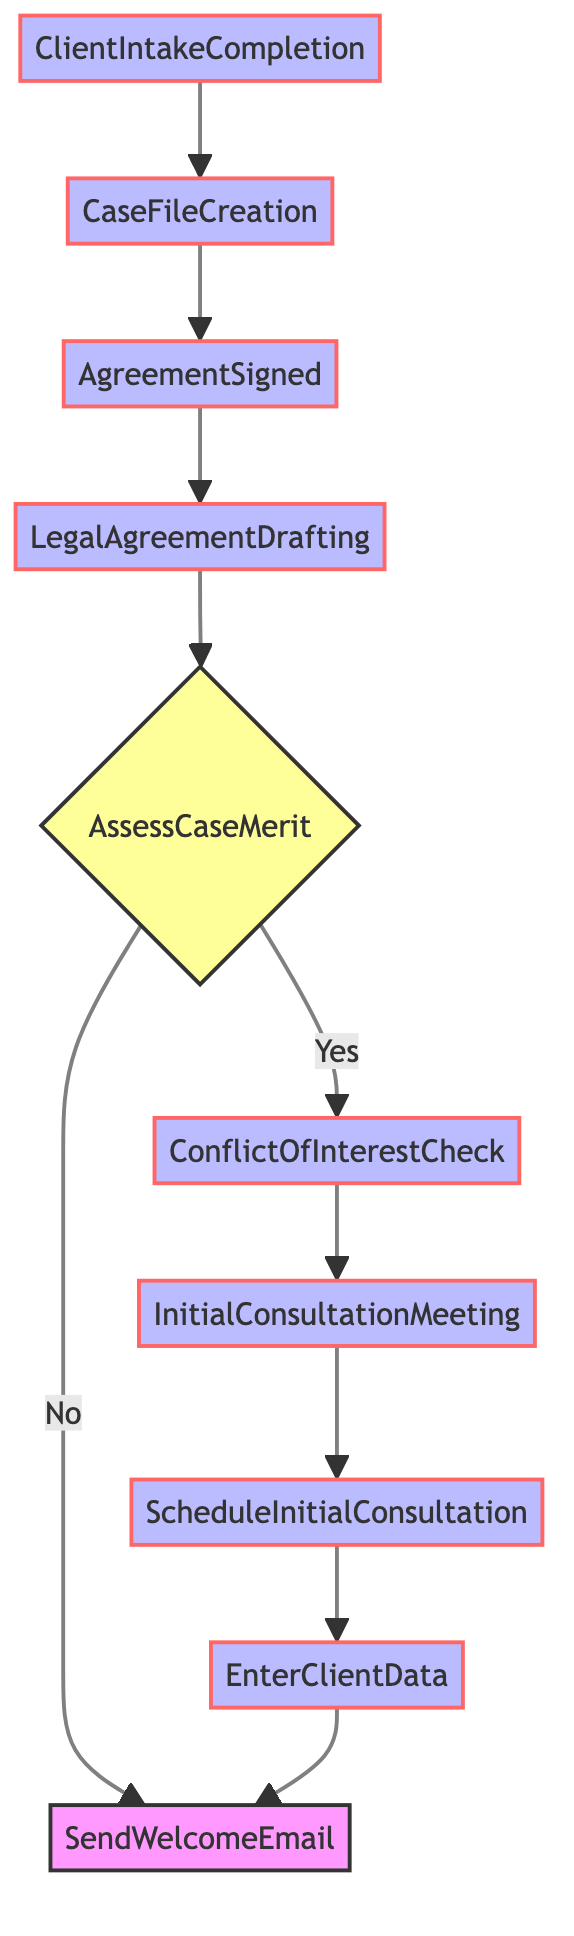What is the final step in the workflow? The final step in the workflow is "Client Intake Completion," which is at the top of the flowchart. It indicates the completion of the entire intake process.
Answer: Client Intake Completion How many decision points are present in the diagram? The diagram has one decision point, which is represented by the diamond shape labeled "AssessCaseMerit." This is where the flow can go in two different directions based on the evaluation.
Answer: 1 What comes immediately after "Legal Agreement Drafting"? The step that comes immediately after "Legal Agreement Drafting" is "Agreement Signed." This indicates that the legal representation agreement is finalized following its drafting.
Answer: Agreement Signed What action does the workflow take if the case merit is evaluated as "No"? If the case merit is evaluated as "No," the workflow directs to "Send Welcome Email." This indicates that the client is acknowledged without proceeding further with the case.
Answer: Send Welcome Email What step is performed after "Conflict of Interest Check"? After "Conflict of Interest Check," the next step is "Initial Consultation Meeting." This means the consultation with the client follows the conflict assessment.
Answer: Initial Consultation Meeting How many total process steps are represented in the flowchart? The flowchart consists of eight process steps: "Client Intake Completion," "Case File Creation," "Agreement Signed," "Legal Agreement Drafting," "Conflict of Interest Check," "Initial Consultation Meeting," "Schedule Initial Consultation," and "Enter Client Data."
Answer: 8 If the client data entry step is completed, what is the next action? After the "Enter Client Data" step is completed, the next action according to the flowchart is to go to "Send Welcome Email." This shows that client data entry leads to welcoming the client.
Answer: Send Welcome Email What does the arrow from "Assess Case Merit" to "Send Welcome Email" signify? The arrow from "Assess Case Merit" to "Send Welcome Email" signifies that if the case merit is found to be lacking (evaluated as "No"), the workflow will direct to sending a welcome email instead of continuing the process.
Answer: It signifies lack of case merit 